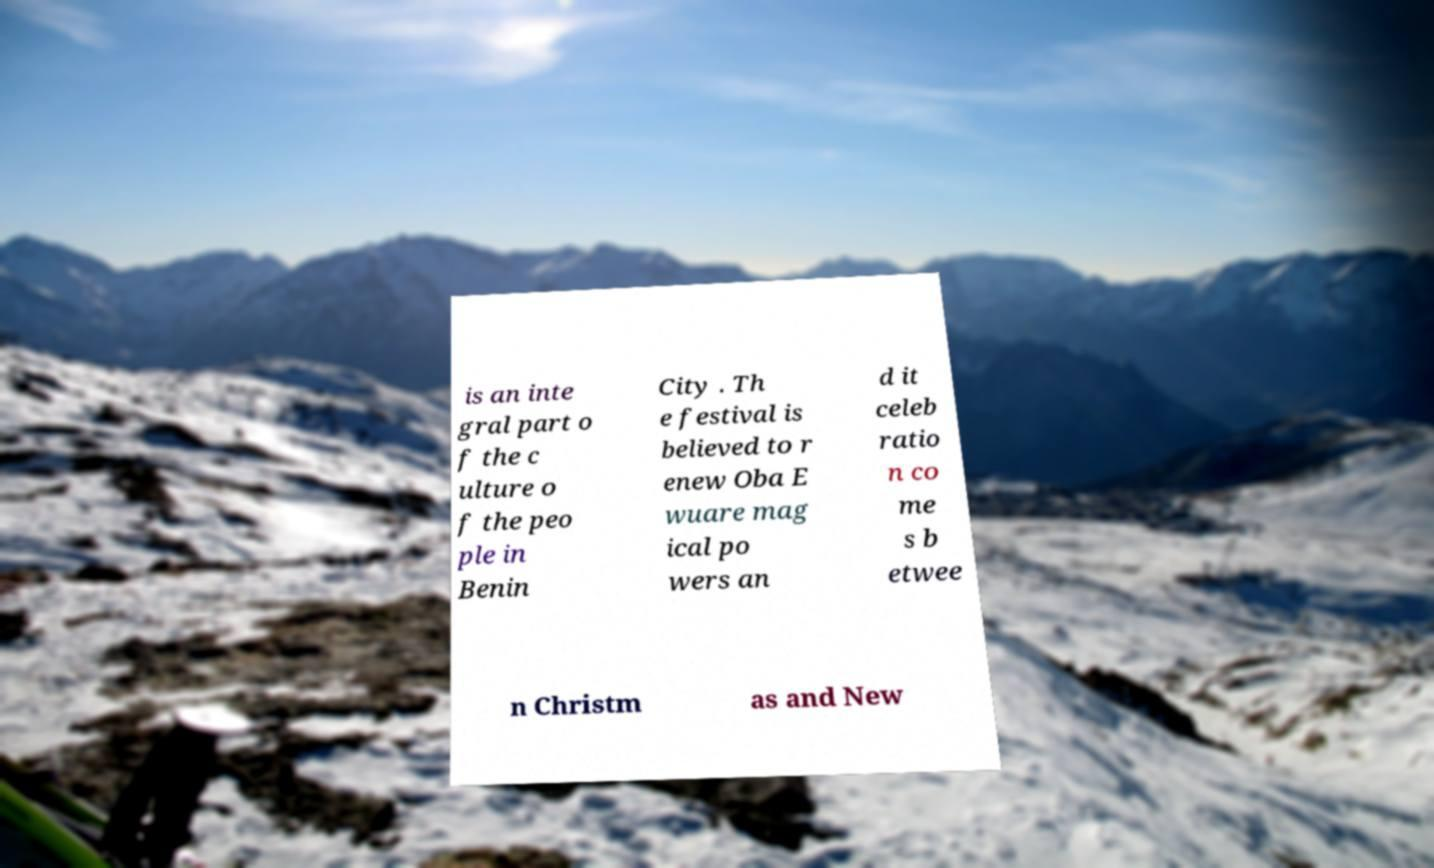What messages or text are displayed in this image? I need them in a readable, typed format. is an inte gral part o f the c ulture o f the peo ple in Benin City . Th e festival is believed to r enew Oba E wuare mag ical po wers an d it celeb ratio n co me s b etwee n Christm as and New 